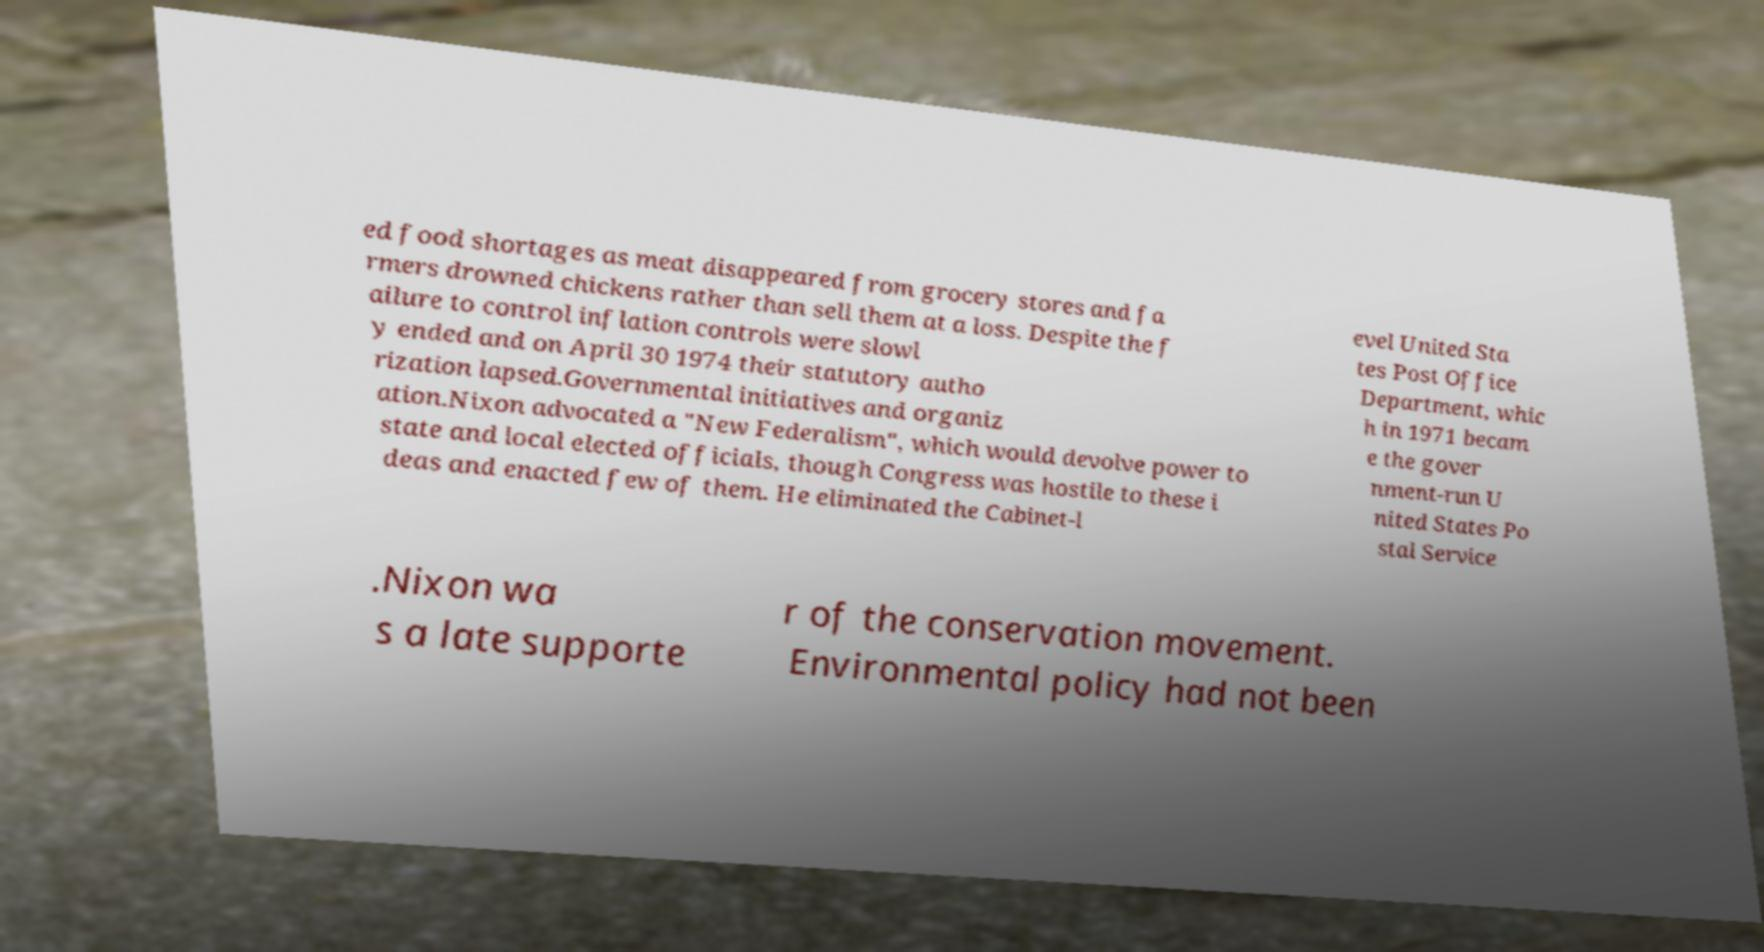I need the written content from this picture converted into text. Can you do that? ed food shortages as meat disappeared from grocery stores and fa rmers drowned chickens rather than sell them at a loss. Despite the f ailure to control inflation controls were slowl y ended and on April 30 1974 their statutory autho rization lapsed.Governmental initiatives and organiz ation.Nixon advocated a "New Federalism", which would devolve power to state and local elected officials, though Congress was hostile to these i deas and enacted few of them. He eliminated the Cabinet-l evel United Sta tes Post Office Department, whic h in 1971 becam e the gover nment-run U nited States Po stal Service .Nixon wa s a late supporte r of the conservation movement. Environmental policy had not been 